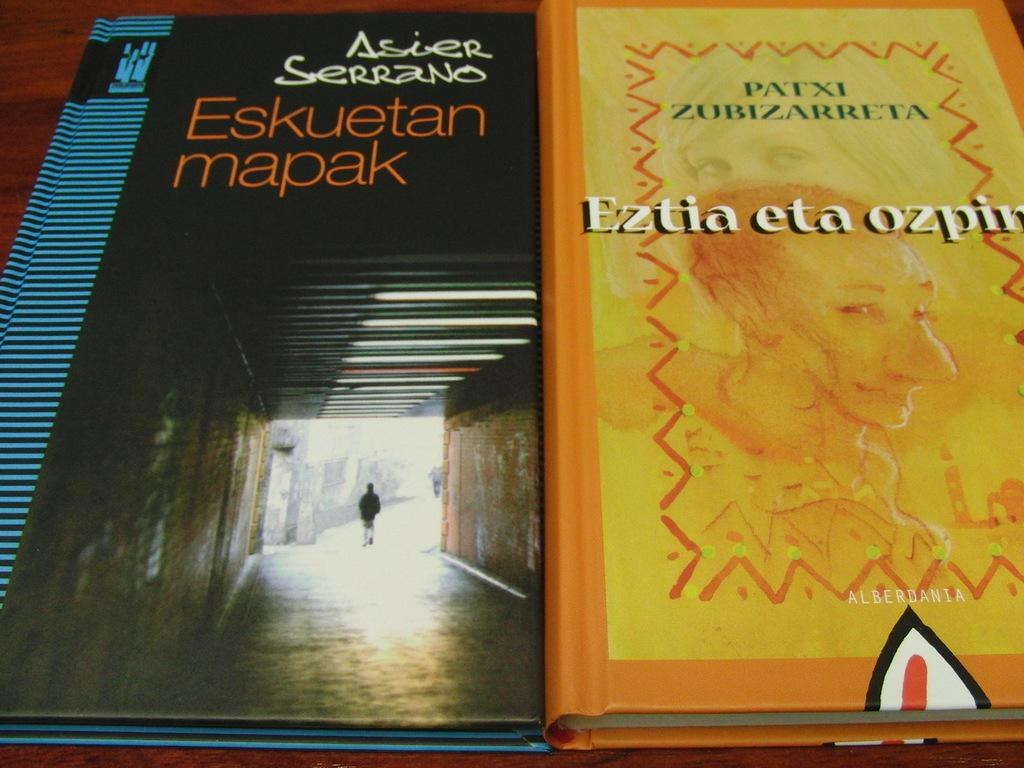Provide a one-sentence caption for the provided image. Two books, one titled Eskuetan mapak, sit side by side. 